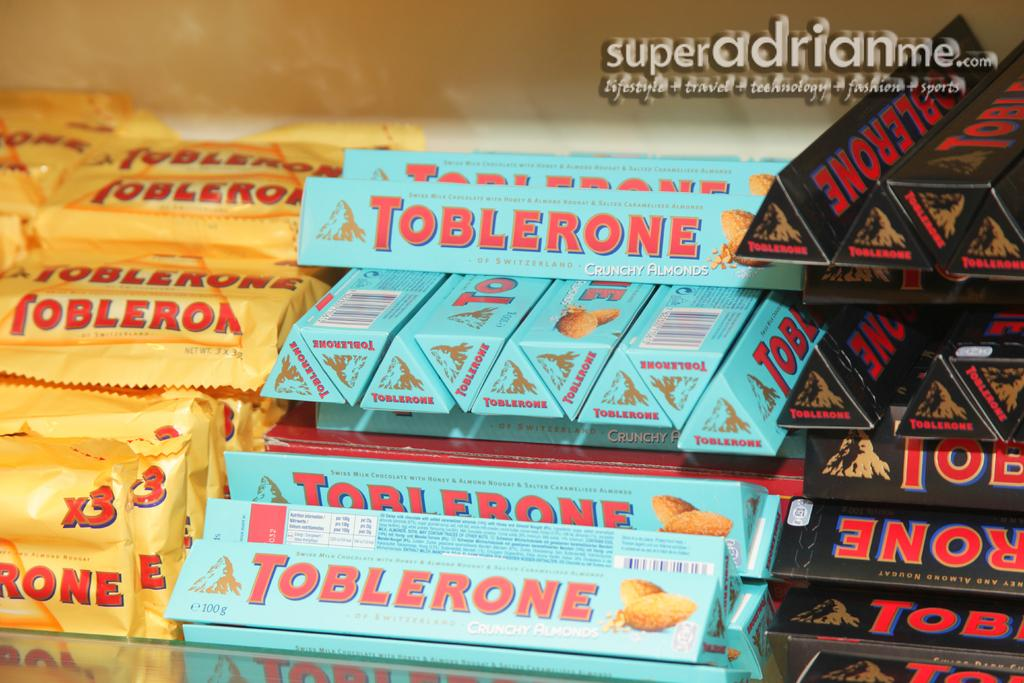<image>
Write a terse but informative summary of the picture. A bin full of three different flavors of Toblerone 